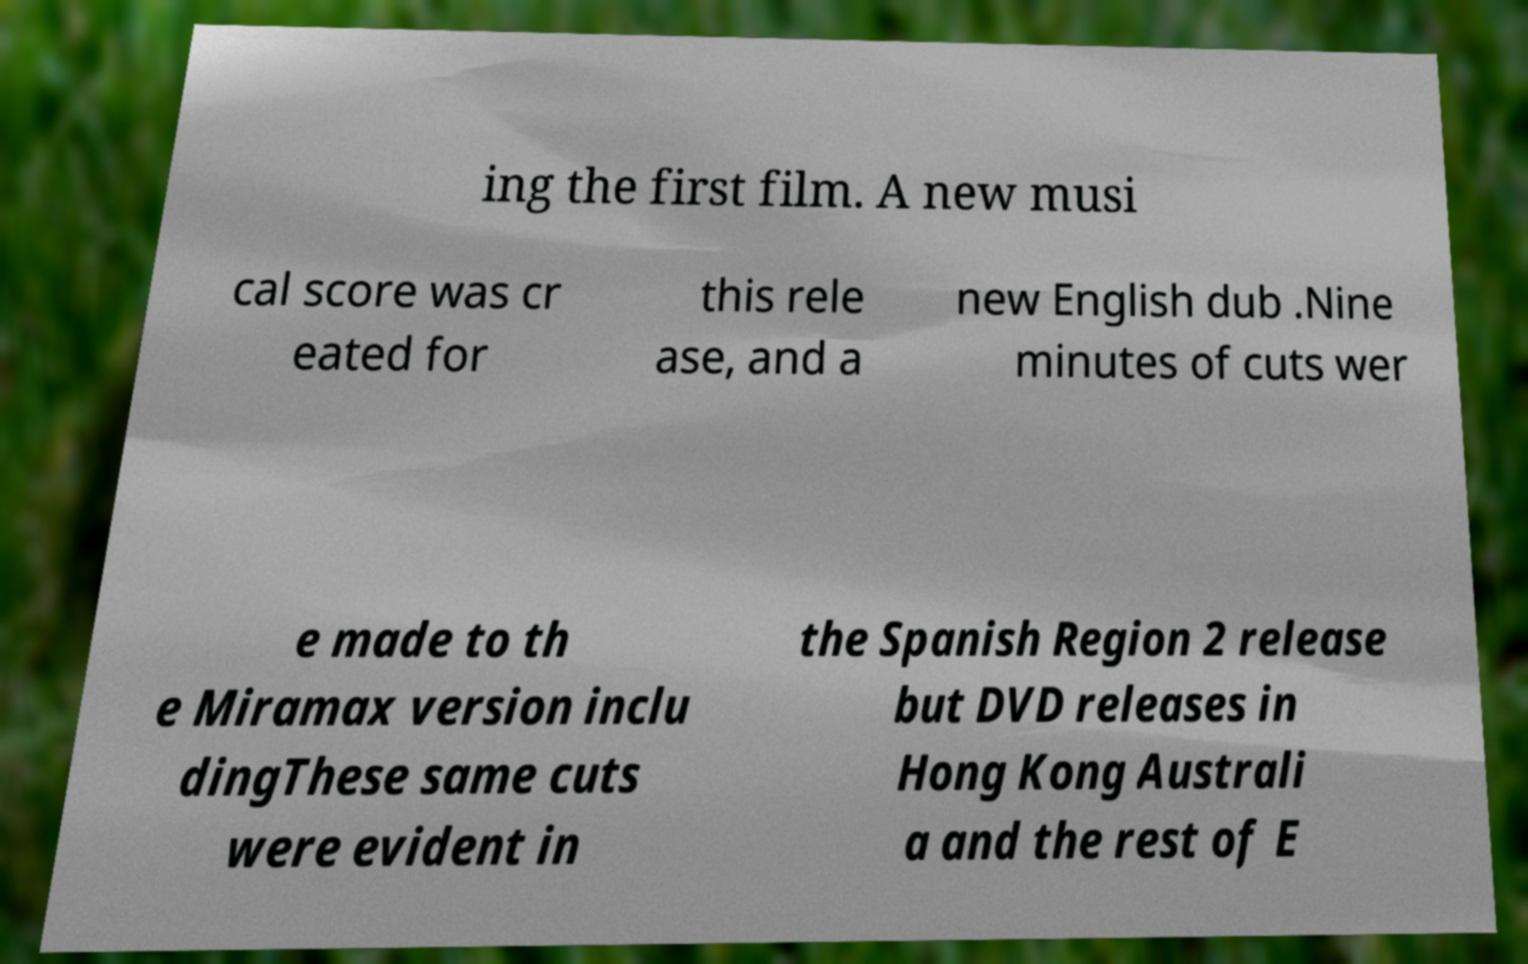There's text embedded in this image that I need extracted. Can you transcribe it verbatim? ing the first film. A new musi cal score was cr eated for this rele ase, and a new English dub .Nine minutes of cuts wer e made to th e Miramax version inclu dingThese same cuts were evident in the Spanish Region 2 release but DVD releases in Hong Kong Australi a and the rest of E 